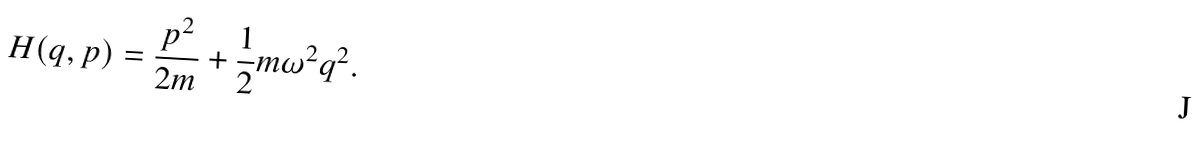Convert formula to latex. <formula><loc_0><loc_0><loc_500><loc_500>H ( q , p ) = \frac { p ^ { 2 } } { 2 m } + \frac { 1 } { 2 } m \omega ^ { 2 } q ^ { 2 } .</formula> 